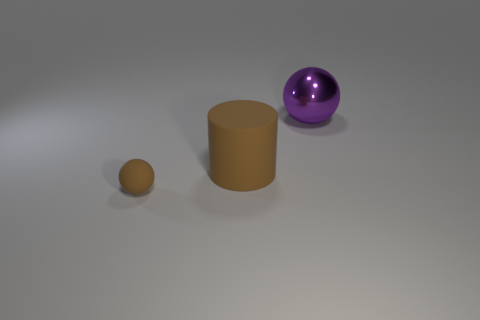There is a matte cylinder that is the same color as the matte ball; what size is it?
Your answer should be very brief. Large. What size is the purple metal thing that is the same shape as the small brown rubber object?
Your answer should be compact. Large. The object that is both in front of the large sphere and to the right of the small rubber thing has what shape?
Your answer should be compact. Cylinder. There is a object right of the brown thing to the right of the sphere that is in front of the shiny object; what is it made of?
Your response must be concise. Metal. Are there more brown balls behind the large purple metal sphere than rubber balls that are behind the brown rubber sphere?
Ensure brevity in your answer.  No. How many brown spheres have the same material as the big brown cylinder?
Offer a very short reply. 1. There is a brown thing to the left of the large brown object; is its shape the same as the object right of the brown rubber cylinder?
Provide a succinct answer. Yes. The matte thing that is behind the tiny thing is what color?
Keep it short and to the point. Brown. Are there any tiny brown things of the same shape as the big purple object?
Keep it short and to the point. Yes. What is the material of the small sphere?
Keep it short and to the point. Rubber. 